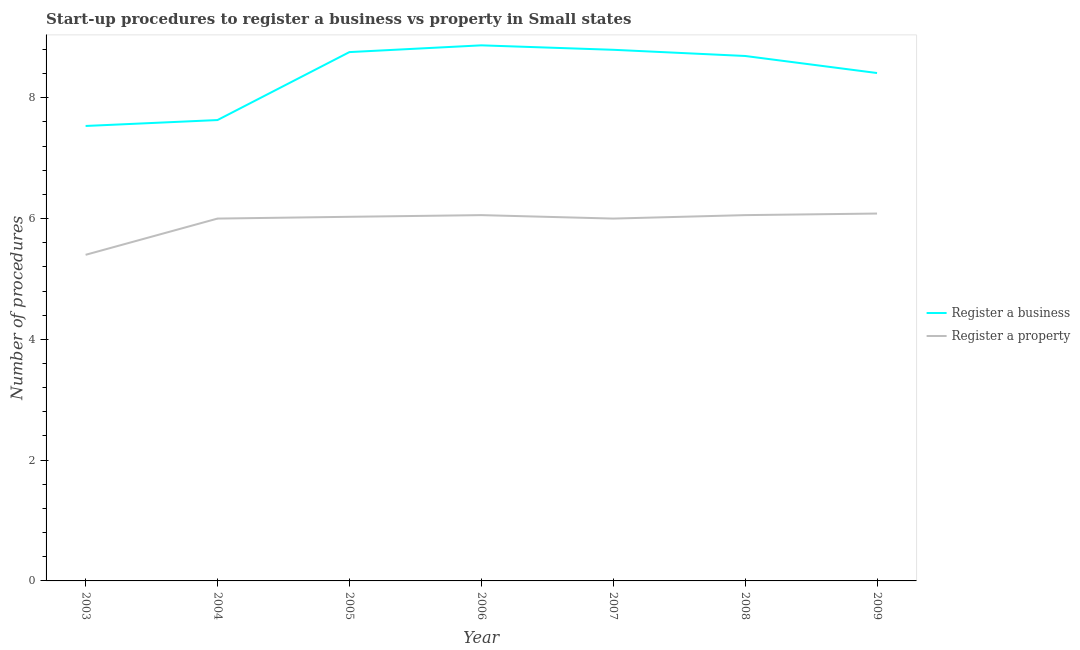Is the number of lines equal to the number of legend labels?
Offer a terse response. Yes. What is the number of procedures to register a property in 2008?
Your answer should be very brief. 6.06. Across all years, what is the maximum number of procedures to register a property?
Give a very brief answer. 6.08. Across all years, what is the minimum number of procedures to register a property?
Make the answer very short. 5.4. What is the total number of procedures to register a business in the graph?
Provide a succinct answer. 58.69. What is the difference between the number of procedures to register a property in 2004 and that in 2008?
Keep it short and to the point. -0.06. What is the difference between the number of procedures to register a business in 2004 and the number of procedures to register a property in 2008?
Ensure brevity in your answer.  1.57. What is the average number of procedures to register a property per year?
Offer a terse response. 5.95. In the year 2008, what is the difference between the number of procedures to register a business and number of procedures to register a property?
Offer a very short reply. 2.64. What is the ratio of the number of procedures to register a property in 2004 to that in 2009?
Offer a very short reply. 0.99. Is the difference between the number of procedures to register a property in 2003 and 2006 greater than the difference between the number of procedures to register a business in 2003 and 2006?
Your answer should be very brief. Yes. What is the difference between the highest and the second highest number of procedures to register a business?
Your answer should be compact. 0.07. What is the difference between the highest and the lowest number of procedures to register a business?
Give a very brief answer. 1.34. Is the sum of the number of procedures to register a property in 2008 and 2009 greater than the maximum number of procedures to register a business across all years?
Provide a succinct answer. Yes. Is the number of procedures to register a business strictly greater than the number of procedures to register a property over the years?
Give a very brief answer. Yes. Are the values on the major ticks of Y-axis written in scientific E-notation?
Keep it short and to the point. No. Does the graph contain grids?
Provide a short and direct response. No. What is the title of the graph?
Ensure brevity in your answer.  Start-up procedures to register a business vs property in Small states. What is the label or title of the Y-axis?
Make the answer very short. Number of procedures. What is the Number of procedures in Register a business in 2003?
Offer a very short reply. 7.53. What is the Number of procedures of Register a property in 2003?
Offer a terse response. 5.4. What is the Number of procedures in Register a business in 2004?
Offer a very short reply. 7.63. What is the Number of procedures in Register a property in 2004?
Keep it short and to the point. 6. What is the Number of procedures of Register a business in 2005?
Make the answer very short. 8.76. What is the Number of procedures in Register a property in 2005?
Make the answer very short. 6.03. What is the Number of procedures in Register a business in 2006?
Ensure brevity in your answer.  8.87. What is the Number of procedures of Register a property in 2006?
Keep it short and to the point. 6.06. What is the Number of procedures of Register a business in 2007?
Your answer should be very brief. 8.79. What is the Number of procedures of Register a property in 2007?
Your response must be concise. 6. What is the Number of procedures of Register a business in 2008?
Your answer should be very brief. 8.69. What is the Number of procedures in Register a property in 2008?
Keep it short and to the point. 6.06. What is the Number of procedures of Register a business in 2009?
Give a very brief answer. 8.41. What is the Number of procedures of Register a property in 2009?
Offer a very short reply. 6.08. Across all years, what is the maximum Number of procedures in Register a business?
Offer a very short reply. 8.87. Across all years, what is the maximum Number of procedures of Register a property?
Offer a very short reply. 6.08. Across all years, what is the minimum Number of procedures of Register a business?
Provide a short and direct response. 7.53. What is the total Number of procedures in Register a business in the graph?
Provide a succinct answer. 58.69. What is the total Number of procedures in Register a property in the graph?
Offer a very short reply. 41.63. What is the difference between the Number of procedures in Register a business in 2003 and that in 2004?
Keep it short and to the point. -0.1. What is the difference between the Number of procedures in Register a property in 2003 and that in 2004?
Your response must be concise. -0.6. What is the difference between the Number of procedures of Register a business in 2003 and that in 2005?
Your response must be concise. -1.22. What is the difference between the Number of procedures of Register a property in 2003 and that in 2005?
Provide a succinct answer. -0.63. What is the difference between the Number of procedures in Register a business in 2003 and that in 2006?
Offer a very short reply. -1.34. What is the difference between the Number of procedures in Register a property in 2003 and that in 2006?
Make the answer very short. -0.66. What is the difference between the Number of procedures of Register a business in 2003 and that in 2007?
Your answer should be compact. -1.26. What is the difference between the Number of procedures of Register a property in 2003 and that in 2007?
Provide a short and direct response. -0.6. What is the difference between the Number of procedures in Register a business in 2003 and that in 2008?
Keep it short and to the point. -1.16. What is the difference between the Number of procedures in Register a property in 2003 and that in 2008?
Provide a short and direct response. -0.66. What is the difference between the Number of procedures of Register a business in 2003 and that in 2009?
Ensure brevity in your answer.  -0.88. What is the difference between the Number of procedures of Register a property in 2003 and that in 2009?
Make the answer very short. -0.68. What is the difference between the Number of procedures in Register a business in 2004 and that in 2005?
Provide a succinct answer. -1.13. What is the difference between the Number of procedures in Register a property in 2004 and that in 2005?
Your answer should be very brief. -0.03. What is the difference between the Number of procedures of Register a business in 2004 and that in 2006?
Offer a terse response. -1.24. What is the difference between the Number of procedures in Register a property in 2004 and that in 2006?
Ensure brevity in your answer.  -0.06. What is the difference between the Number of procedures of Register a business in 2004 and that in 2007?
Ensure brevity in your answer.  -1.16. What is the difference between the Number of procedures in Register a business in 2004 and that in 2008?
Keep it short and to the point. -1.06. What is the difference between the Number of procedures of Register a property in 2004 and that in 2008?
Provide a short and direct response. -0.06. What is the difference between the Number of procedures of Register a business in 2004 and that in 2009?
Offer a terse response. -0.78. What is the difference between the Number of procedures of Register a property in 2004 and that in 2009?
Your answer should be compact. -0.08. What is the difference between the Number of procedures of Register a business in 2005 and that in 2006?
Provide a succinct answer. -0.11. What is the difference between the Number of procedures in Register a property in 2005 and that in 2006?
Your answer should be compact. -0.03. What is the difference between the Number of procedures of Register a business in 2005 and that in 2007?
Offer a terse response. -0.04. What is the difference between the Number of procedures of Register a property in 2005 and that in 2007?
Provide a short and direct response. 0.03. What is the difference between the Number of procedures in Register a business in 2005 and that in 2008?
Make the answer very short. 0.06. What is the difference between the Number of procedures in Register a property in 2005 and that in 2008?
Ensure brevity in your answer.  -0.03. What is the difference between the Number of procedures in Register a business in 2005 and that in 2009?
Your answer should be very brief. 0.35. What is the difference between the Number of procedures in Register a property in 2005 and that in 2009?
Offer a terse response. -0.05. What is the difference between the Number of procedures in Register a business in 2006 and that in 2007?
Provide a short and direct response. 0.07. What is the difference between the Number of procedures in Register a property in 2006 and that in 2007?
Provide a short and direct response. 0.06. What is the difference between the Number of procedures of Register a business in 2006 and that in 2008?
Ensure brevity in your answer.  0.18. What is the difference between the Number of procedures of Register a business in 2006 and that in 2009?
Make the answer very short. 0.46. What is the difference between the Number of procedures in Register a property in 2006 and that in 2009?
Ensure brevity in your answer.  -0.03. What is the difference between the Number of procedures of Register a business in 2007 and that in 2008?
Offer a very short reply. 0.1. What is the difference between the Number of procedures of Register a property in 2007 and that in 2008?
Provide a succinct answer. -0.06. What is the difference between the Number of procedures in Register a business in 2007 and that in 2009?
Your answer should be very brief. 0.38. What is the difference between the Number of procedures in Register a property in 2007 and that in 2009?
Provide a short and direct response. -0.08. What is the difference between the Number of procedures of Register a business in 2008 and that in 2009?
Make the answer very short. 0.28. What is the difference between the Number of procedures in Register a property in 2008 and that in 2009?
Provide a succinct answer. -0.03. What is the difference between the Number of procedures in Register a business in 2003 and the Number of procedures in Register a property in 2004?
Ensure brevity in your answer.  1.53. What is the difference between the Number of procedures in Register a business in 2003 and the Number of procedures in Register a property in 2005?
Provide a short and direct response. 1.5. What is the difference between the Number of procedures of Register a business in 2003 and the Number of procedures of Register a property in 2006?
Your response must be concise. 1.48. What is the difference between the Number of procedures in Register a business in 2003 and the Number of procedures in Register a property in 2007?
Provide a short and direct response. 1.53. What is the difference between the Number of procedures of Register a business in 2003 and the Number of procedures of Register a property in 2008?
Your answer should be compact. 1.48. What is the difference between the Number of procedures in Register a business in 2003 and the Number of procedures in Register a property in 2009?
Provide a succinct answer. 1.45. What is the difference between the Number of procedures of Register a business in 2004 and the Number of procedures of Register a property in 2005?
Ensure brevity in your answer.  1.6. What is the difference between the Number of procedures of Register a business in 2004 and the Number of procedures of Register a property in 2006?
Keep it short and to the point. 1.57. What is the difference between the Number of procedures in Register a business in 2004 and the Number of procedures in Register a property in 2007?
Your answer should be very brief. 1.63. What is the difference between the Number of procedures of Register a business in 2004 and the Number of procedures of Register a property in 2008?
Provide a succinct answer. 1.57. What is the difference between the Number of procedures in Register a business in 2004 and the Number of procedures in Register a property in 2009?
Offer a terse response. 1.55. What is the difference between the Number of procedures in Register a business in 2005 and the Number of procedures in Register a property in 2006?
Keep it short and to the point. 2.7. What is the difference between the Number of procedures of Register a business in 2005 and the Number of procedures of Register a property in 2007?
Give a very brief answer. 2.76. What is the difference between the Number of procedures of Register a business in 2005 and the Number of procedures of Register a property in 2008?
Offer a very short reply. 2.7. What is the difference between the Number of procedures in Register a business in 2005 and the Number of procedures in Register a property in 2009?
Provide a succinct answer. 2.67. What is the difference between the Number of procedures in Register a business in 2006 and the Number of procedures in Register a property in 2007?
Your answer should be compact. 2.87. What is the difference between the Number of procedures of Register a business in 2006 and the Number of procedures of Register a property in 2008?
Offer a terse response. 2.81. What is the difference between the Number of procedures of Register a business in 2006 and the Number of procedures of Register a property in 2009?
Make the answer very short. 2.79. What is the difference between the Number of procedures of Register a business in 2007 and the Number of procedures of Register a property in 2008?
Make the answer very short. 2.74. What is the difference between the Number of procedures in Register a business in 2007 and the Number of procedures in Register a property in 2009?
Provide a succinct answer. 2.71. What is the difference between the Number of procedures of Register a business in 2008 and the Number of procedures of Register a property in 2009?
Your answer should be compact. 2.61. What is the average Number of procedures in Register a business per year?
Offer a terse response. 8.38. What is the average Number of procedures in Register a property per year?
Give a very brief answer. 5.95. In the year 2003, what is the difference between the Number of procedures in Register a business and Number of procedures in Register a property?
Give a very brief answer. 2.13. In the year 2004, what is the difference between the Number of procedures in Register a business and Number of procedures in Register a property?
Ensure brevity in your answer.  1.63. In the year 2005, what is the difference between the Number of procedures of Register a business and Number of procedures of Register a property?
Your response must be concise. 2.73. In the year 2006, what is the difference between the Number of procedures of Register a business and Number of procedures of Register a property?
Your response must be concise. 2.81. In the year 2007, what is the difference between the Number of procedures in Register a business and Number of procedures in Register a property?
Give a very brief answer. 2.79. In the year 2008, what is the difference between the Number of procedures of Register a business and Number of procedures of Register a property?
Offer a terse response. 2.64. In the year 2009, what is the difference between the Number of procedures in Register a business and Number of procedures in Register a property?
Ensure brevity in your answer.  2.33. What is the ratio of the Number of procedures of Register a business in 2003 to that in 2004?
Keep it short and to the point. 0.99. What is the ratio of the Number of procedures in Register a business in 2003 to that in 2005?
Ensure brevity in your answer.  0.86. What is the ratio of the Number of procedures in Register a property in 2003 to that in 2005?
Give a very brief answer. 0.9. What is the ratio of the Number of procedures in Register a business in 2003 to that in 2006?
Offer a terse response. 0.85. What is the ratio of the Number of procedures of Register a property in 2003 to that in 2006?
Make the answer very short. 0.89. What is the ratio of the Number of procedures of Register a business in 2003 to that in 2007?
Offer a terse response. 0.86. What is the ratio of the Number of procedures of Register a business in 2003 to that in 2008?
Provide a succinct answer. 0.87. What is the ratio of the Number of procedures in Register a property in 2003 to that in 2008?
Give a very brief answer. 0.89. What is the ratio of the Number of procedures in Register a business in 2003 to that in 2009?
Your answer should be very brief. 0.9. What is the ratio of the Number of procedures of Register a property in 2003 to that in 2009?
Keep it short and to the point. 0.89. What is the ratio of the Number of procedures in Register a business in 2004 to that in 2005?
Keep it short and to the point. 0.87. What is the ratio of the Number of procedures of Register a business in 2004 to that in 2006?
Provide a short and direct response. 0.86. What is the ratio of the Number of procedures in Register a property in 2004 to that in 2006?
Make the answer very short. 0.99. What is the ratio of the Number of procedures of Register a business in 2004 to that in 2007?
Give a very brief answer. 0.87. What is the ratio of the Number of procedures of Register a property in 2004 to that in 2007?
Your answer should be very brief. 1. What is the ratio of the Number of procedures of Register a business in 2004 to that in 2008?
Your answer should be compact. 0.88. What is the ratio of the Number of procedures in Register a property in 2004 to that in 2008?
Provide a succinct answer. 0.99. What is the ratio of the Number of procedures of Register a business in 2004 to that in 2009?
Ensure brevity in your answer.  0.91. What is the ratio of the Number of procedures in Register a property in 2004 to that in 2009?
Offer a very short reply. 0.99. What is the ratio of the Number of procedures of Register a business in 2005 to that in 2006?
Provide a succinct answer. 0.99. What is the ratio of the Number of procedures in Register a business in 2005 to that in 2007?
Your answer should be very brief. 1. What is the ratio of the Number of procedures in Register a business in 2005 to that in 2008?
Your answer should be compact. 1.01. What is the ratio of the Number of procedures in Register a property in 2005 to that in 2008?
Offer a terse response. 1. What is the ratio of the Number of procedures of Register a business in 2005 to that in 2009?
Give a very brief answer. 1.04. What is the ratio of the Number of procedures of Register a business in 2006 to that in 2007?
Your answer should be very brief. 1.01. What is the ratio of the Number of procedures in Register a property in 2006 to that in 2007?
Offer a very short reply. 1.01. What is the ratio of the Number of procedures in Register a business in 2006 to that in 2008?
Provide a short and direct response. 1.02. What is the ratio of the Number of procedures of Register a property in 2006 to that in 2008?
Offer a very short reply. 1. What is the ratio of the Number of procedures of Register a business in 2006 to that in 2009?
Your answer should be compact. 1.05. What is the ratio of the Number of procedures of Register a business in 2007 to that in 2008?
Provide a succinct answer. 1.01. What is the ratio of the Number of procedures in Register a property in 2007 to that in 2008?
Offer a very short reply. 0.99. What is the ratio of the Number of procedures in Register a business in 2007 to that in 2009?
Your response must be concise. 1.05. What is the ratio of the Number of procedures of Register a property in 2007 to that in 2009?
Your answer should be very brief. 0.99. What is the ratio of the Number of procedures in Register a business in 2008 to that in 2009?
Keep it short and to the point. 1.03. What is the difference between the highest and the second highest Number of procedures in Register a business?
Offer a very short reply. 0.07. What is the difference between the highest and the second highest Number of procedures in Register a property?
Your answer should be compact. 0.03. What is the difference between the highest and the lowest Number of procedures in Register a business?
Your answer should be compact. 1.34. What is the difference between the highest and the lowest Number of procedures of Register a property?
Offer a very short reply. 0.68. 